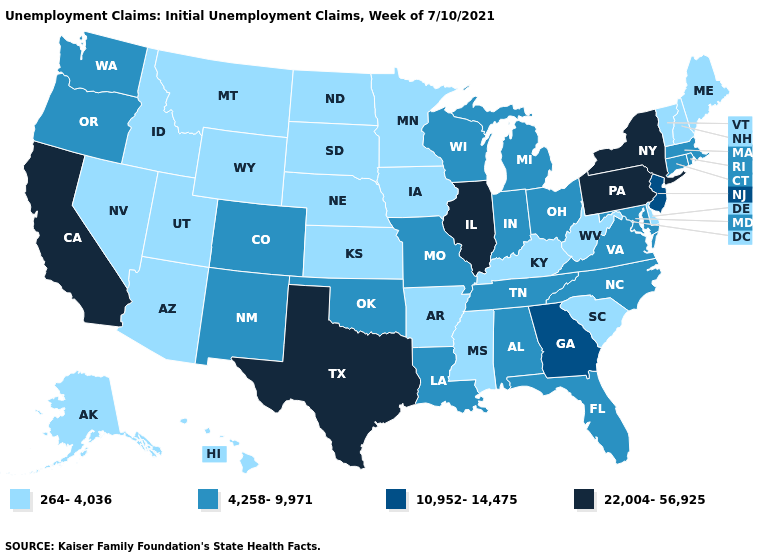Which states have the highest value in the USA?
Answer briefly. California, Illinois, New York, Pennsylvania, Texas. What is the value of Massachusetts?
Keep it brief. 4,258-9,971. What is the value of Rhode Island?
Answer briefly. 4,258-9,971. What is the value of Arkansas?
Concise answer only. 264-4,036. What is the value of Iowa?
Concise answer only. 264-4,036. Name the states that have a value in the range 4,258-9,971?
Concise answer only. Alabama, Colorado, Connecticut, Florida, Indiana, Louisiana, Maryland, Massachusetts, Michigan, Missouri, New Mexico, North Carolina, Ohio, Oklahoma, Oregon, Rhode Island, Tennessee, Virginia, Washington, Wisconsin. Does Illinois have the highest value in the MidWest?
Give a very brief answer. Yes. Does the first symbol in the legend represent the smallest category?
Quick response, please. Yes. What is the highest value in the South ?
Keep it brief. 22,004-56,925. What is the highest value in the Northeast ?
Write a very short answer. 22,004-56,925. Does Kansas have the highest value in the USA?
Give a very brief answer. No. Among the states that border New Hampshire , which have the highest value?
Keep it brief. Massachusetts. Which states have the highest value in the USA?
Keep it brief. California, Illinois, New York, Pennsylvania, Texas. Does Vermont have the same value as Mississippi?
Keep it brief. Yes. 